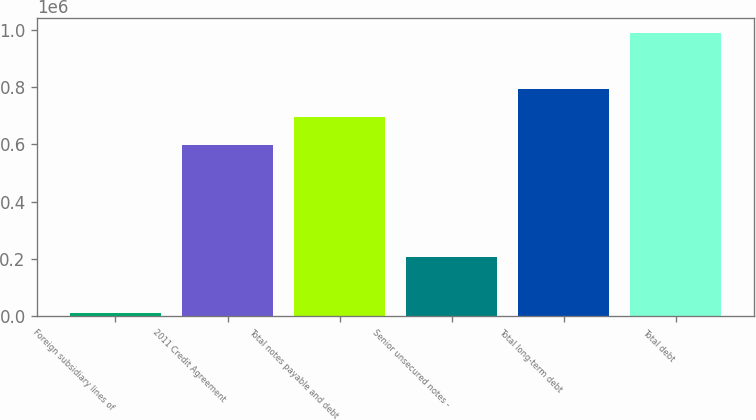Convert chart to OTSL. <chart><loc_0><loc_0><loc_500><loc_500><bar_chart><fcel>Foreign subsidiary lines of<fcel>2011 Credit Agreement<fcel>Total notes payable and debt<fcel>Senior unsecured notes -<fcel>Total long-term debt<fcel>Total debt<nl><fcel>10832<fcel>598832<fcel>696832<fcel>206832<fcel>794832<fcel>990832<nl></chart> 